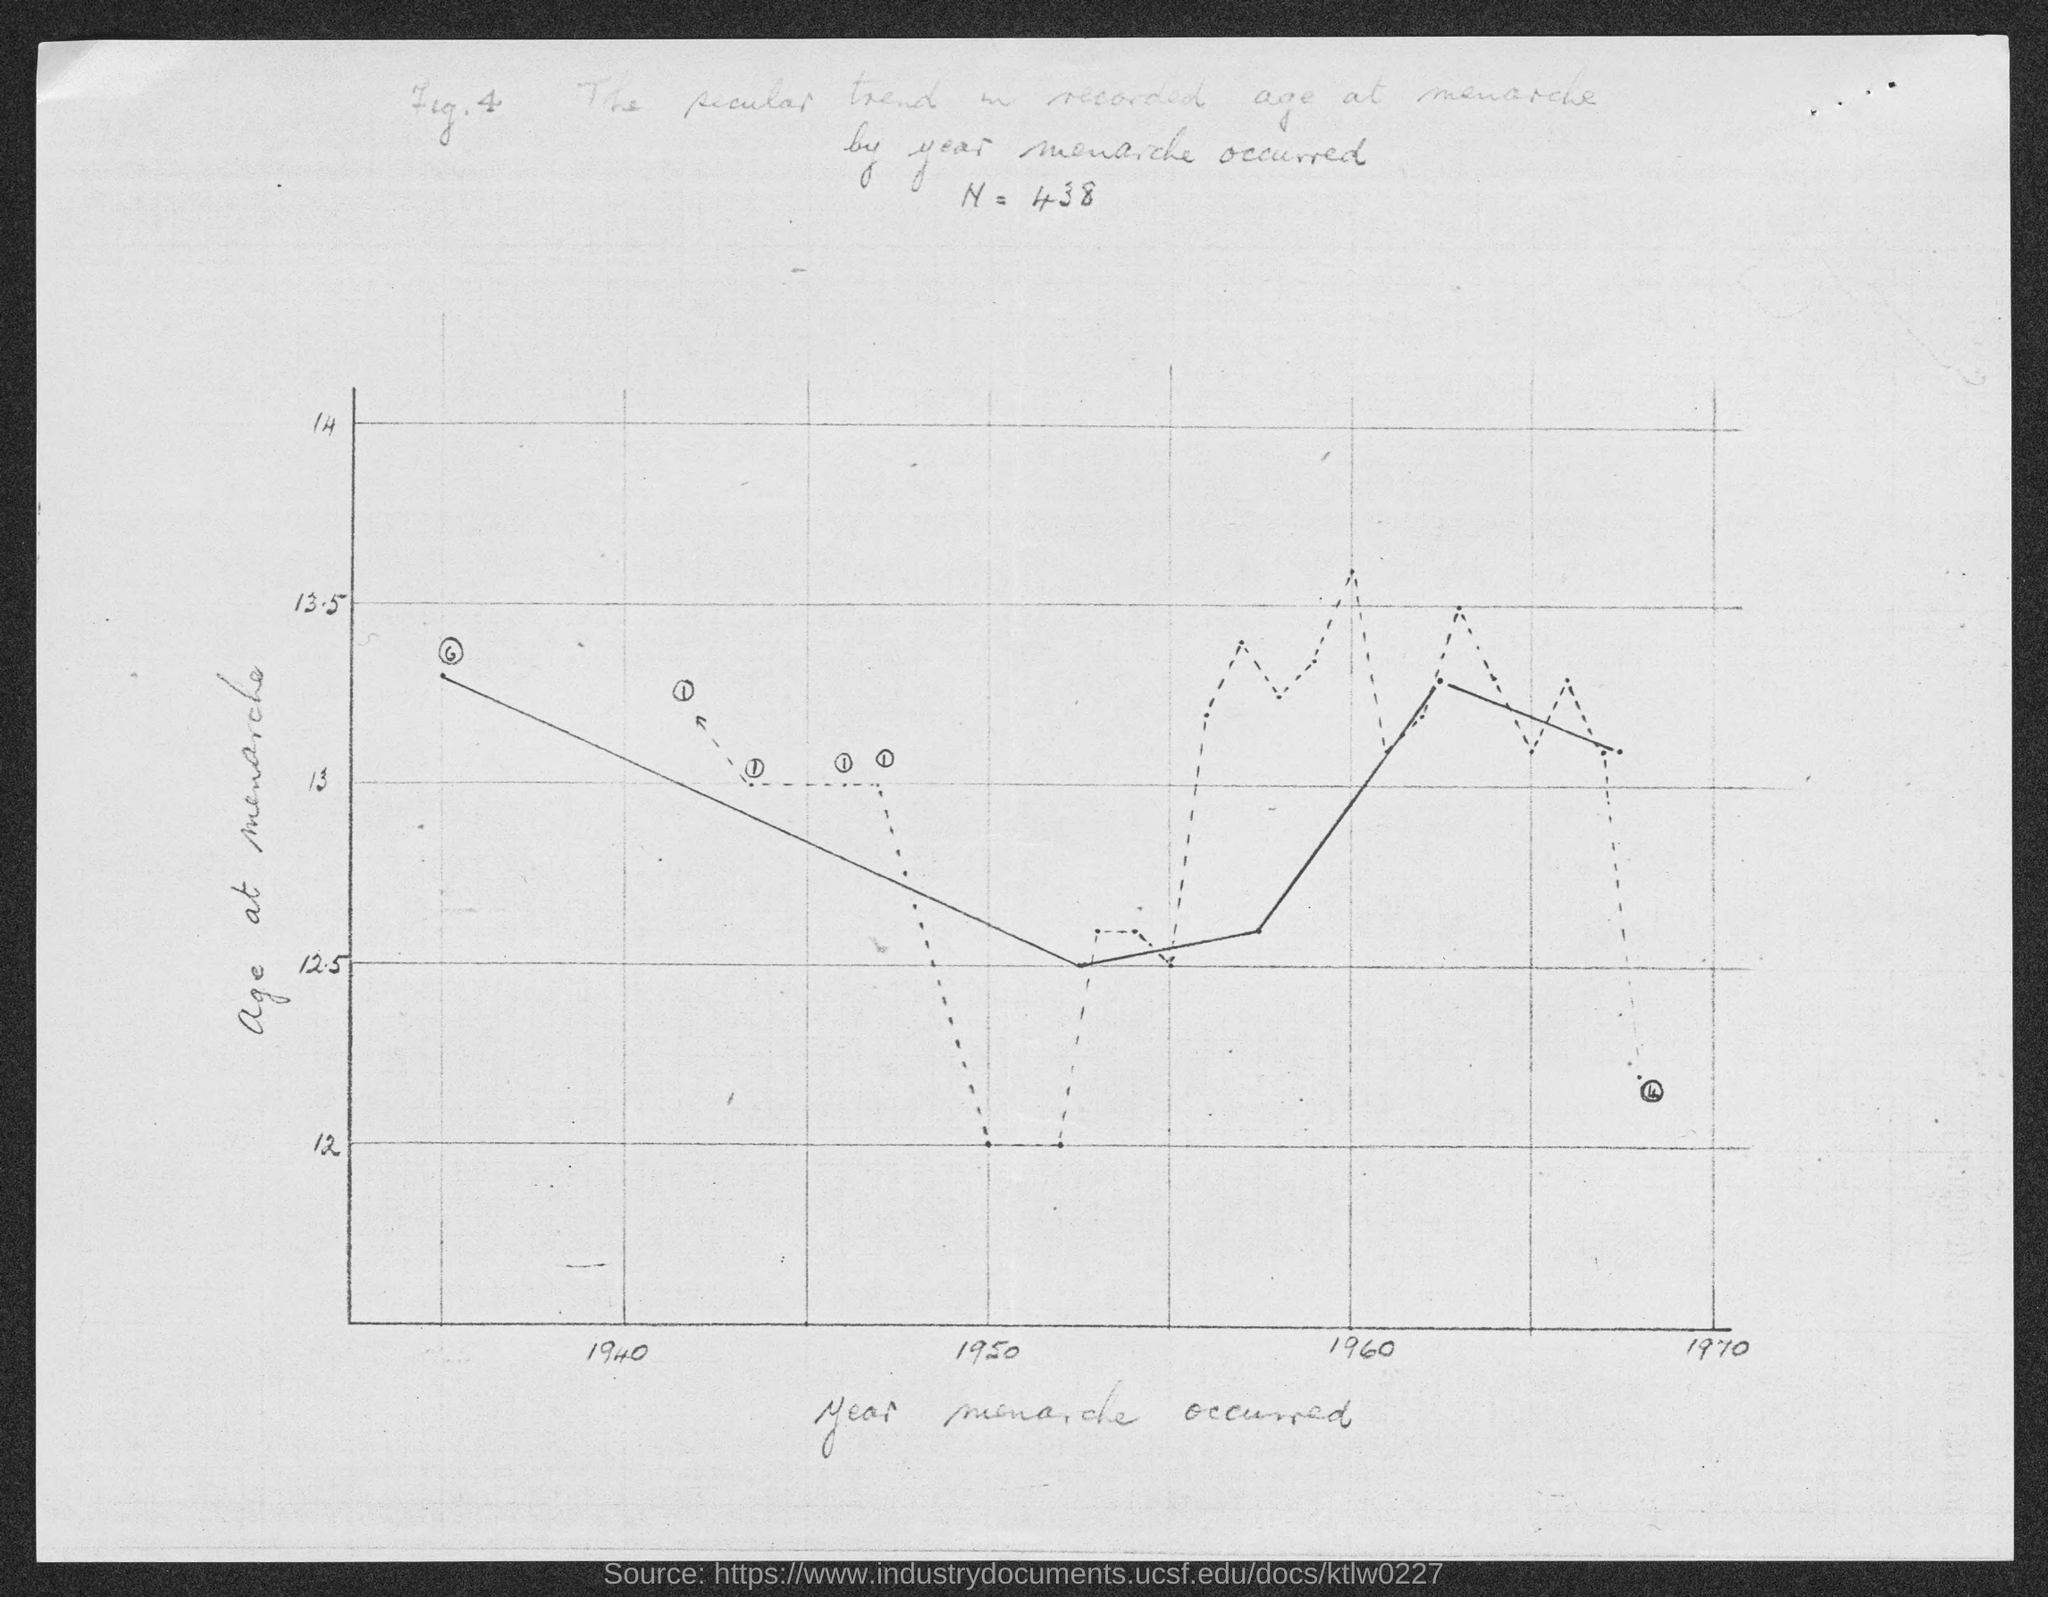Outline some significant characteristics in this image. The figure number is [X]." where X is the actual figure number (e.g. Fig. 4 if the original text is "What is the figure number? Fig. 4.."). The value of N is 438. The y-axis in the scatter plot displays the age at menarche, which is the age when a female experiences her first menstrual period. 